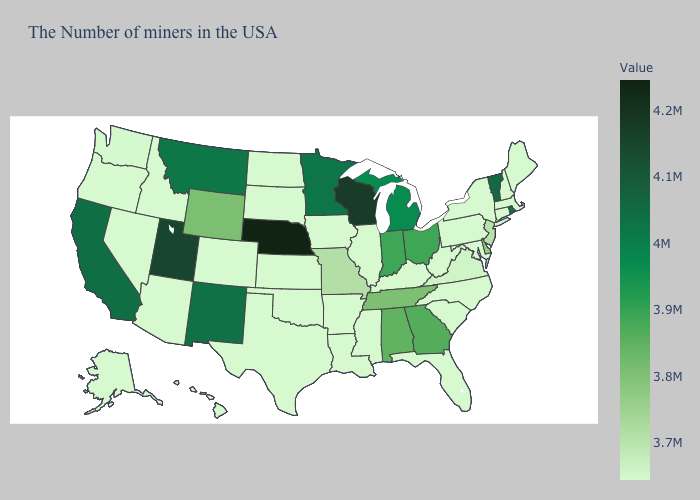Among the states that border Rhode Island , which have the lowest value?
Quick response, please. Massachusetts, Connecticut. Does Vermont have the highest value in the Northeast?
Concise answer only. Yes. Does Tennessee have the lowest value in the USA?
Concise answer only. No. Among the states that border South Dakota , which have the lowest value?
Short answer required. Iowa, North Dakota. 